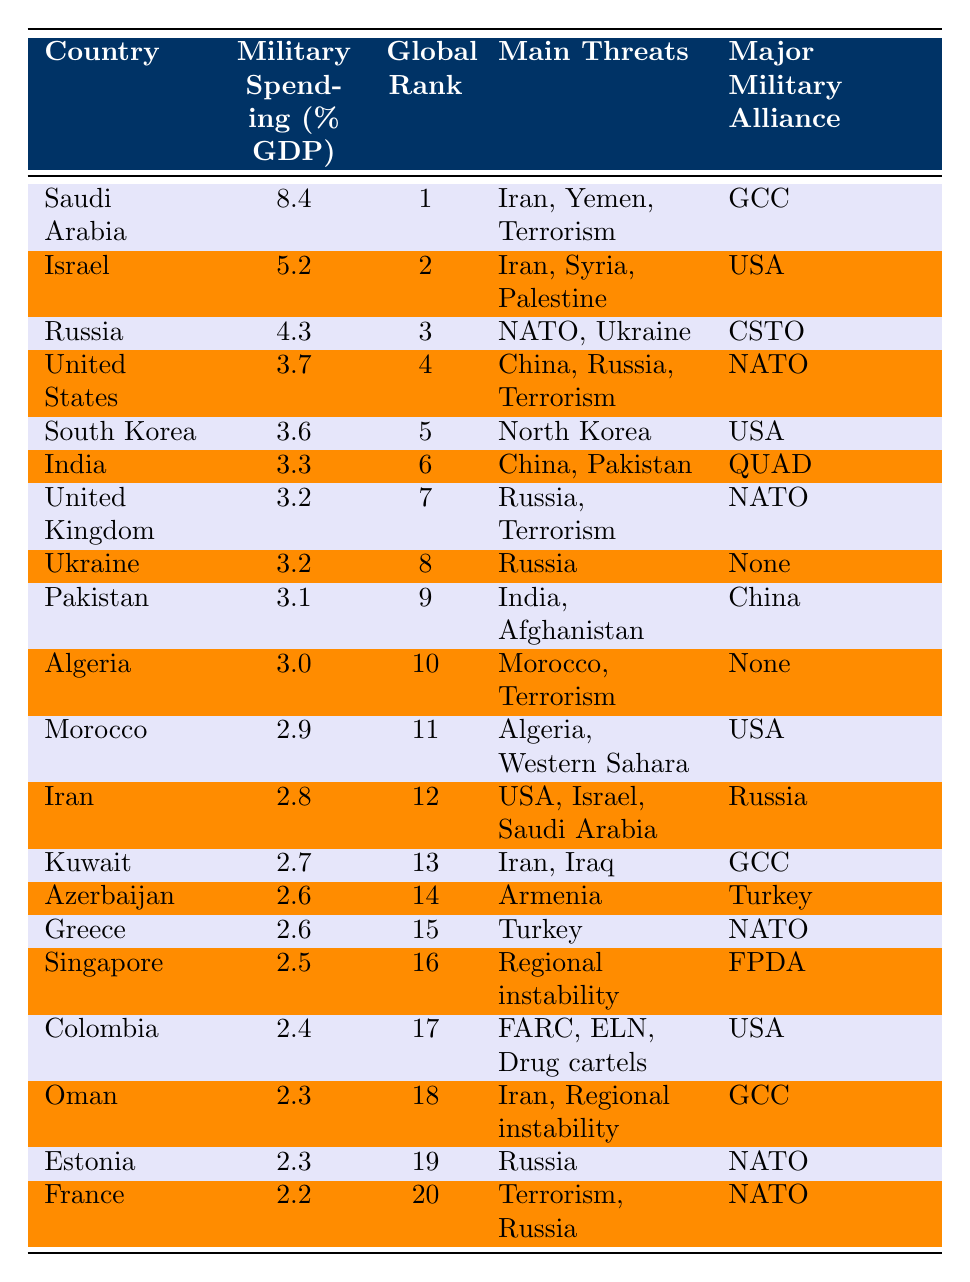What country has the highest military spending as a percentage of GDP? The table shows that Saudi Arabia has the highest military spending percentage at 8.4%.
Answer: Saudi Arabia Which country ranks fourth in military spending as a percentage of GDP? Referring to the Global Rank column, the United States is listed as ranking fourth with a military spending percentage of 3.7%.
Answer: United States How many countries have military spending percentages greater than or equal to 3.0%? The countries with spending percentages of 3.0% or more are Saudi Arabia, Israel, Russia, United States, South Korea, India, United Kingdom, Ukraine, Pakistan, and Algeria, totaling 10 countries.
Answer: 10 What is the average military spending percentage of the top three countries? The spending percentages of the top three countries are 8.4%, 5.2%, and 4.3%. Summing these gives 8.4 + 5.2 + 4.3 = 18. The average is 18 / 3 = 6.0%.
Answer: 6.0% Is it true that all countries in the top 10 have military spending percentages above 3%? Checking the Military Spending Percentage for all top 10 countries, they are 8.4%, 5.2%, 4.3%, 3.7%, 3.6%, 3.3%, 3.2%, 3.2%, 3.1%, and 3.0%, confirming that all are indeed above 3%.
Answer: Yes Which country has the lowest military spending among the top 20? Looking at the Military Spending Percentage, France has the lowest at 2.2%.
Answer: France What are the main threats listed for India? The table indicates that India's main threats are China and Pakistan.
Answer: China, Pakistan How many countries are aligned with NATO among the top 20? The countries aligned with NATO in the table are the United States, United Kingdom, Ukraine, Greece, Estonia, and France, totaling 6 countries.
Answer: 6 Which country's main military alliance is the GCC and what is its spending percentage? Saudi Arabia is aligned with the GCC and has a military spending percentage of 8.4%.
Answer: Saudi Arabia, 8.4% What is the relationship between military spending percentages and global rank for the top three countries? The top three countries have military spending percentages of 8.4%, 5.2%, and 4.3%, corresponding to ranks of 1, 2, and 3 respectively, indicating higher spending correlates with a better rank.
Answer: Higher spending correlates with better rank Which country ranked 13th and what are its main threats? The table shows that Kuwait ranked 13th, with main threats being Iran and Iraq.
Answer: Kuwait, Iran, Iraq 